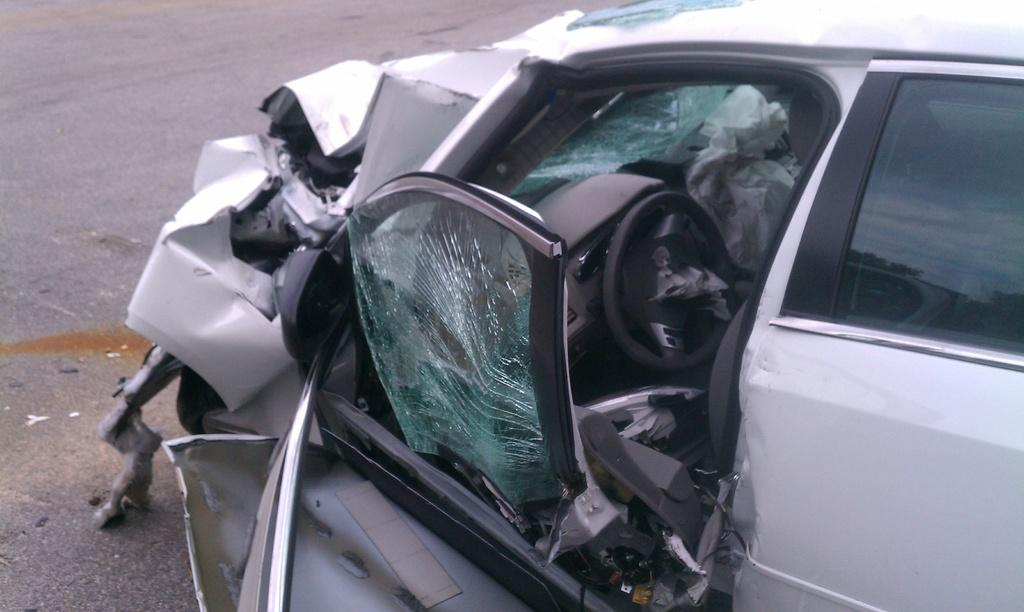What is the main subject of the image? The main subject of the image is a damaged car. Where is the damaged car located? The damaged car is on the road. What part of the car appears to be most affected by the damage? The front part of the car is crushed. What type of toys can be seen scattered around the room in the image? There is no room or toys present in the image; it features a damaged car on the road. 